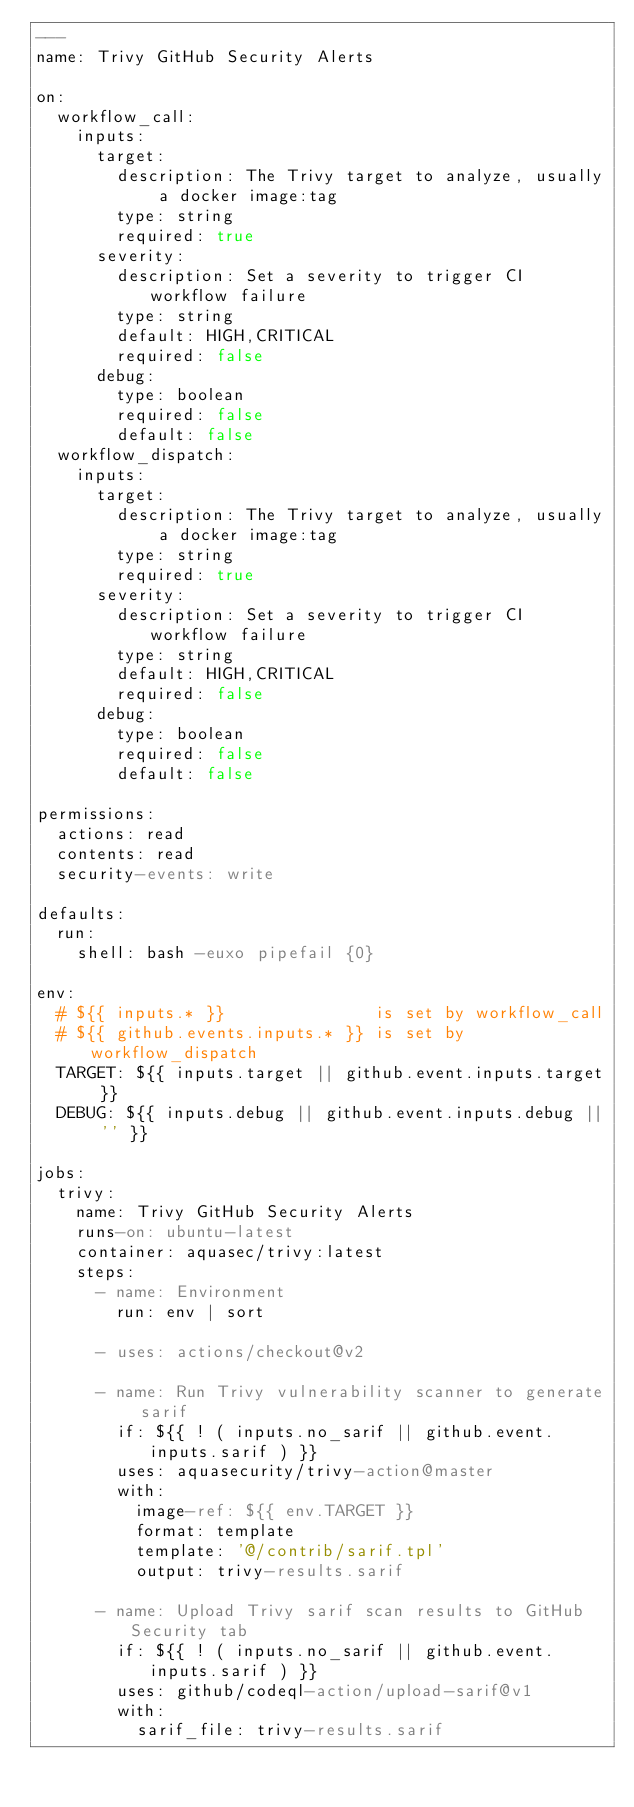Convert code to text. <code><loc_0><loc_0><loc_500><loc_500><_YAML_>---
name: Trivy GitHub Security Alerts

on:
  workflow_call:
    inputs:
      target:
        description: The Trivy target to analyze, usually a docker image:tag
        type: string
        required: true
      severity:
        description: Set a severity to trigger CI workflow failure
        type: string
        default: HIGH,CRITICAL
        required: false
      debug:
        type: boolean
        required: false
        default: false
  workflow_dispatch:
    inputs:
      target:
        description: The Trivy target to analyze, usually a docker image:tag
        type: string
        required: true
      severity:
        description: Set a severity to trigger CI workflow failure
        type: string
        default: HIGH,CRITICAL
        required: false
      debug:
        type: boolean
        required: false
        default: false

permissions:
  actions: read
  contents: read
  security-events: write

defaults:
  run:
    shell: bash -euxo pipefail {0}

env:
  # ${{ inputs.* }}               is set by workflow_call
  # ${{ github.events.inputs.* }} is set by workflow_dispatch
  TARGET: ${{ inputs.target || github.event.inputs.target }}
  DEBUG: ${{ inputs.debug || github.event.inputs.debug || '' }}

jobs:
  trivy:
    name: Trivy GitHub Security Alerts
    runs-on: ubuntu-latest
    container: aquasec/trivy:latest
    steps:
      - name: Environment
        run: env | sort

      - uses: actions/checkout@v2

      - name: Run Trivy vulnerability scanner to generate sarif
        if: ${{ ! ( inputs.no_sarif || github.event.inputs.sarif ) }}
        uses: aquasecurity/trivy-action@master
        with:
          image-ref: ${{ env.TARGET }}
          format: template
          template: '@/contrib/sarif.tpl'
          output: trivy-results.sarif

      - name: Upload Trivy sarif scan results to GitHub Security tab
        if: ${{ ! ( inputs.no_sarif || github.event.inputs.sarif ) }}
        uses: github/codeql-action/upload-sarif@v1
        with:
          sarif_file: trivy-results.sarif
</code> 